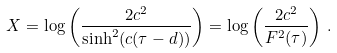Convert formula to latex. <formula><loc_0><loc_0><loc_500><loc_500>X = \log \left ( \frac { 2 c ^ { 2 } } { \sinh ^ { 2 } ( c ( \tau - d ) ) } \right ) = \log \left ( \frac { 2 c ^ { 2 } } { F ^ { 2 } ( \tau ) } \right ) \, .</formula> 